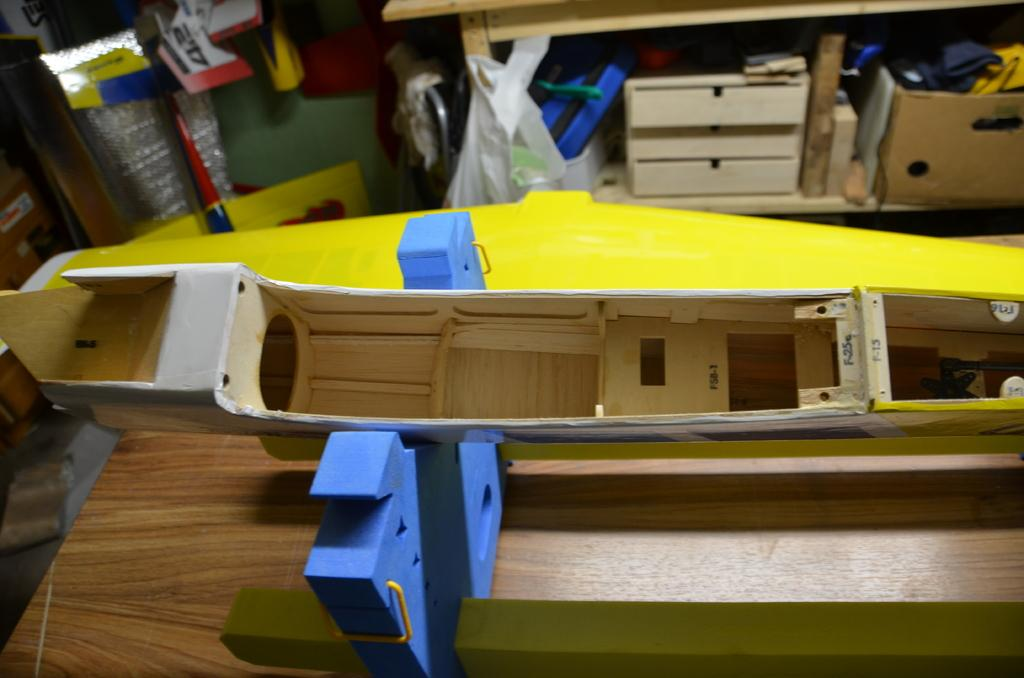What type of objects can be seen on the table in the image? There are wooden objects on the table in the image. What is visible in the background of the image? There is a table, a cartoon box, clothes, and a wall in the background of the image. Can you describe the setting of the image? The image is likely taken in a room, as indicated by the presence of a table and wall. What type of punishment is being administered to the wooden objects in the image? There is no punishment being administered to the wooden objects in the image; they are simply sitting on the table. What sense is being stimulated by the presence of the wooden objects in the image? The wooden objects in the image do not stimulate any specific sense; they are inanimate objects. 